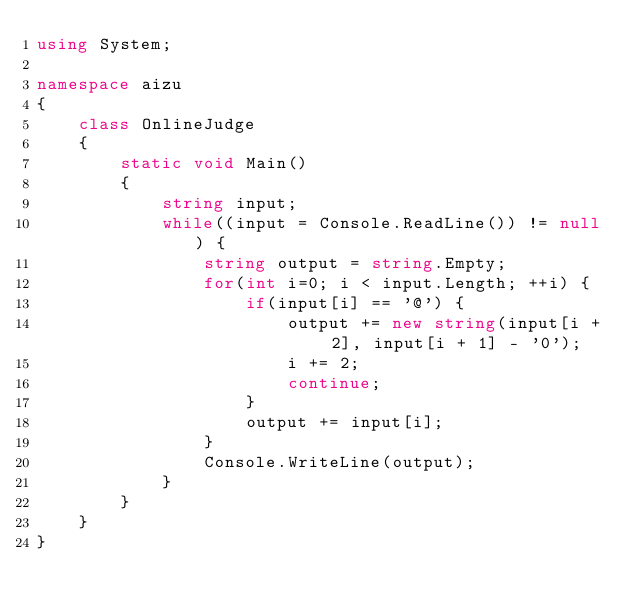Convert code to text. <code><loc_0><loc_0><loc_500><loc_500><_C#_>using System;

namespace aizu
{
    class OnlineJudge
    {
        static void Main()
        {
            string input;
            while((input = Console.ReadLine()) != null) {
                string output = string.Empty;
                for(int i=0; i < input.Length; ++i) {
                    if(input[i] == '@') {
                        output += new string(input[i + 2], input[i + 1] - '0');
                        i += 2;
                        continue;
                    }
                    output += input[i];
                }
                Console.WriteLine(output);
            }
        }
    }
}</code> 